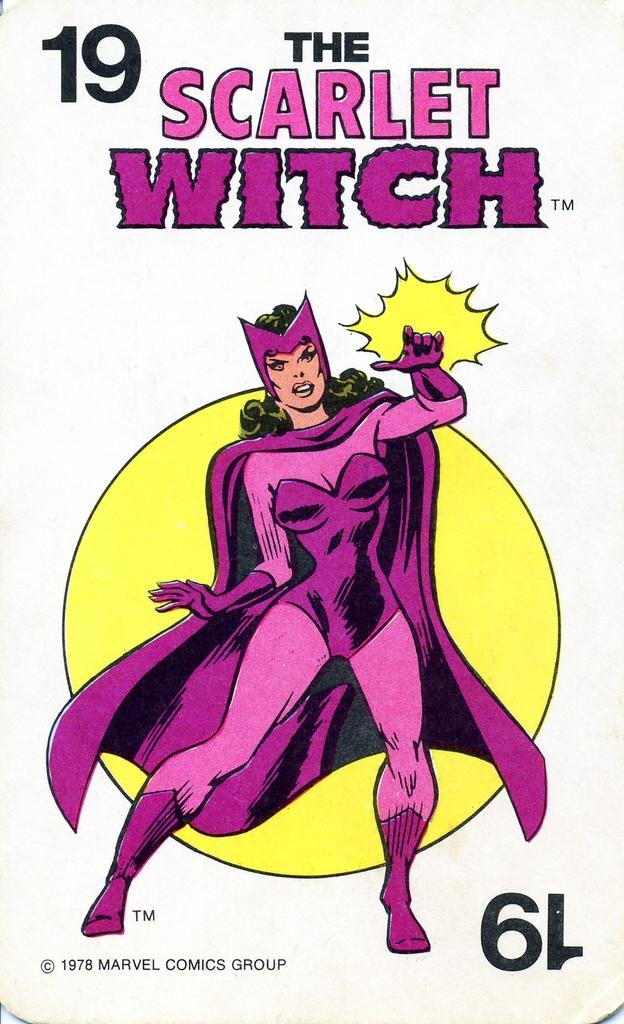What is the main subject of the image? The main subject of the image is an advertisement. What can be seen in the advertisement? The advertisement contains a picture of a woman wearing a costume. Where is the text located on the advertisement? There is text at the top and bottom of the advertisement. What type of cracker is being advertised in the image? There is no cracker being advertised in the image; the advertisement features a woman wearing a costume. How many teeth can be seen in the image? There are no teeth visible in the image. 